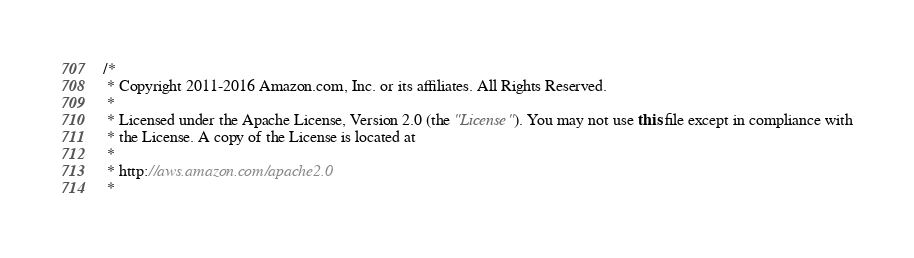Convert code to text. <code><loc_0><loc_0><loc_500><loc_500><_Java_>/*
 * Copyright 2011-2016 Amazon.com, Inc. or its affiliates. All Rights Reserved.
 * 
 * Licensed under the Apache License, Version 2.0 (the "License"). You may not use this file except in compliance with
 * the License. A copy of the License is located at
 * 
 * http://aws.amazon.com/apache2.0
 * </code> 